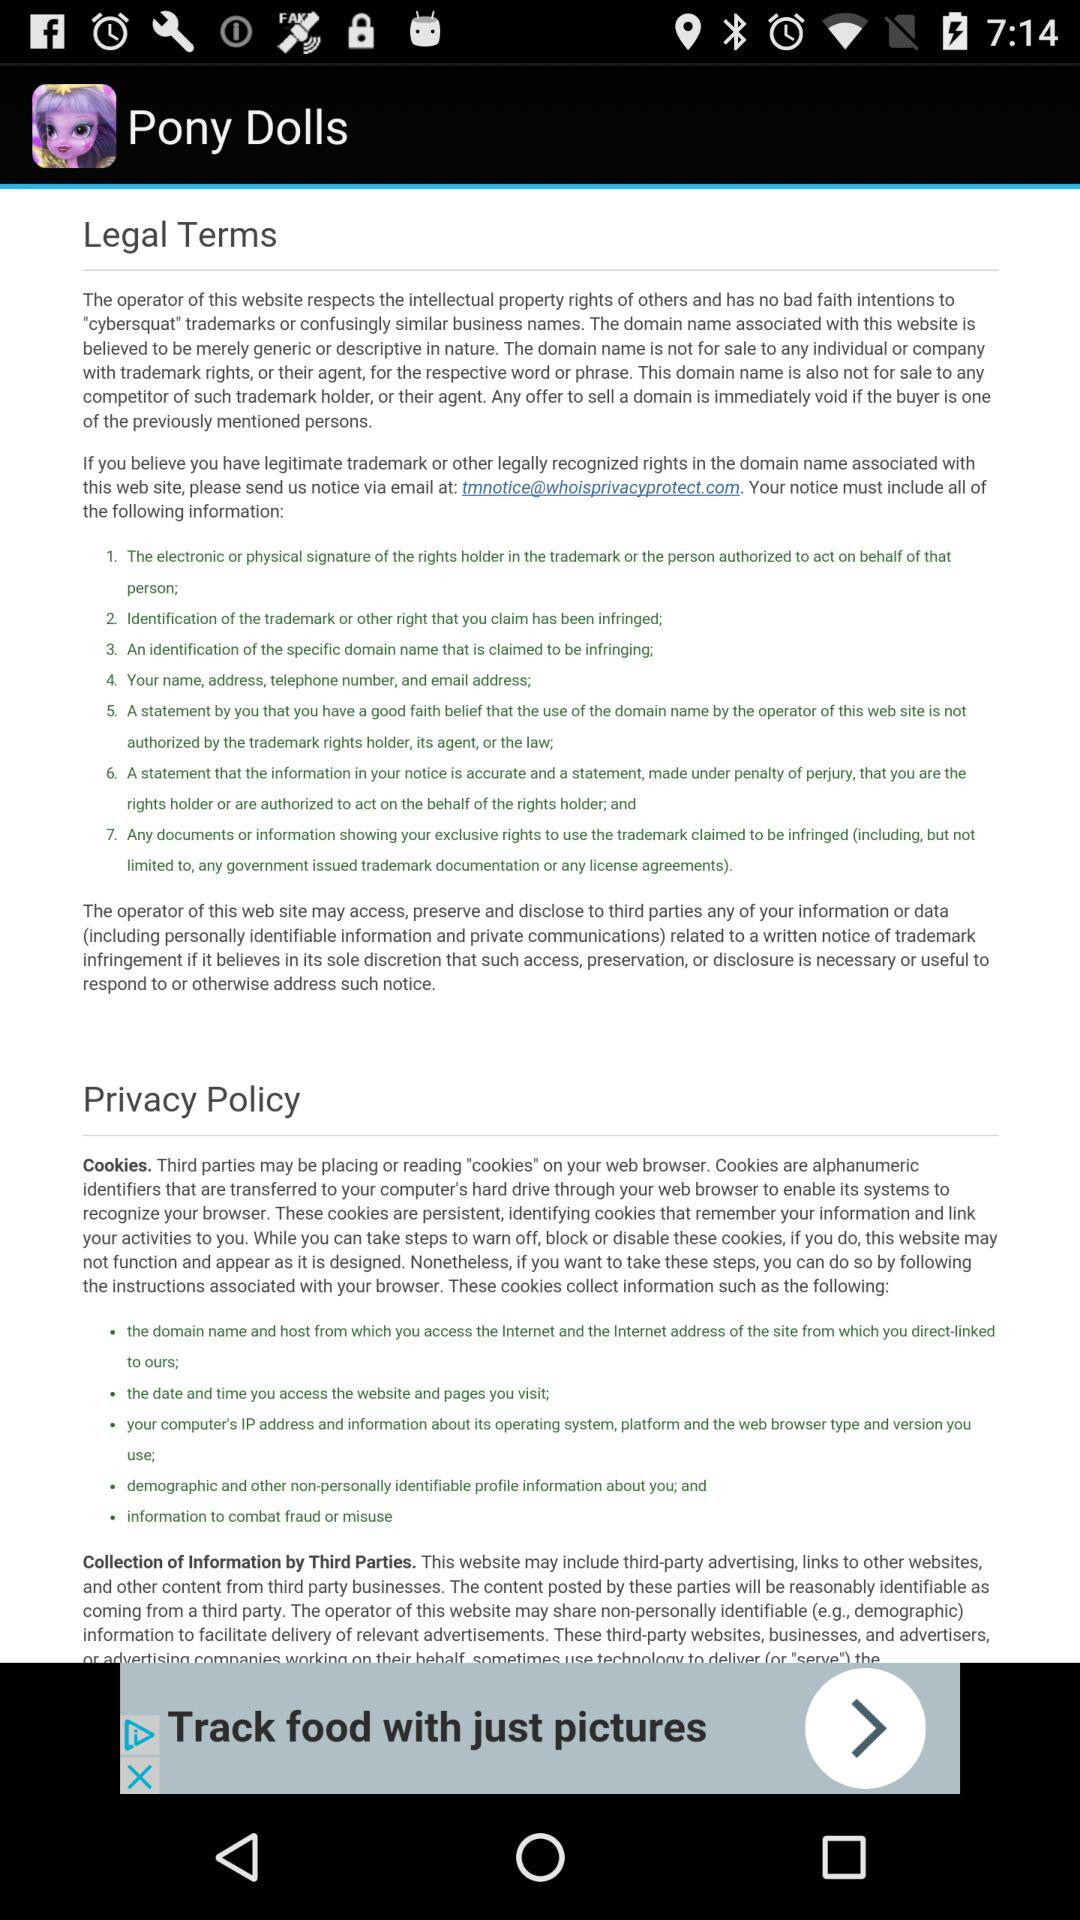What is the application name? The application name is "Pony Dolls". 